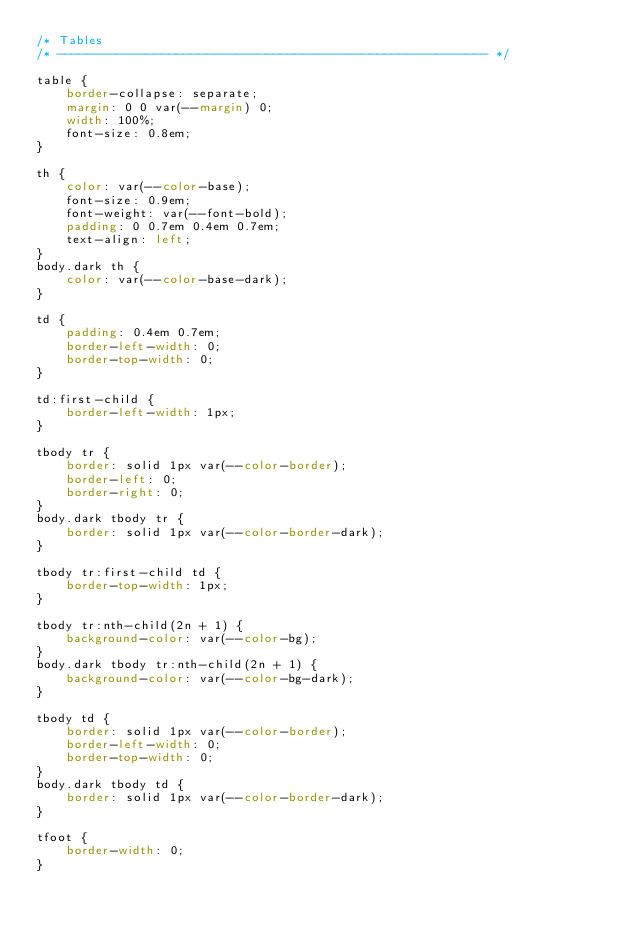Convert code to text. <code><loc_0><loc_0><loc_500><loc_500><_CSS_>/* Tables
/* ---------------------------------------------------------- */

table {
    border-collapse: separate;
    margin: 0 0 var(--margin) 0;
    width: 100%;
    font-size: 0.8em;
}

th {
    color: var(--color-base);
    font-size: 0.9em;
    font-weight: var(--font-bold);
    padding: 0 0.7em 0.4em 0.7em;
    text-align: left;
}
body.dark th {
    color: var(--color-base-dark);
}

td {
    padding: 0.4em 0.7em;
    border-left-width: 0;
    border-top-width: 0;
}

td:first-child {
    border-left-width: 1px;
}

tbody tr {
    border: solid 1px var(--color-border);
    border-left: 0;
    border-right: 0;
}
body.dark tbody tr {
    border: solid 1px var(--color-border-dark);
}

tbody tr:first-child td {
    border-top-width: 1px;
}

tbody tr:nth-child(2n + 1) {
    background-color: var(--color-bg);
}
body.dark tbody tr:nth-child(2n + 1) {
    background-color: var(--color-bg-dark);
}

tbody td {
    border: solid 1px var(--color-border);
    border-left-width: 0;
    border-top-width: 0;
}
body.dark tbody td {
    border: solid 1px var(--color-border-dark);
}

tfoot {
    border-width: 0;
}
</code> 